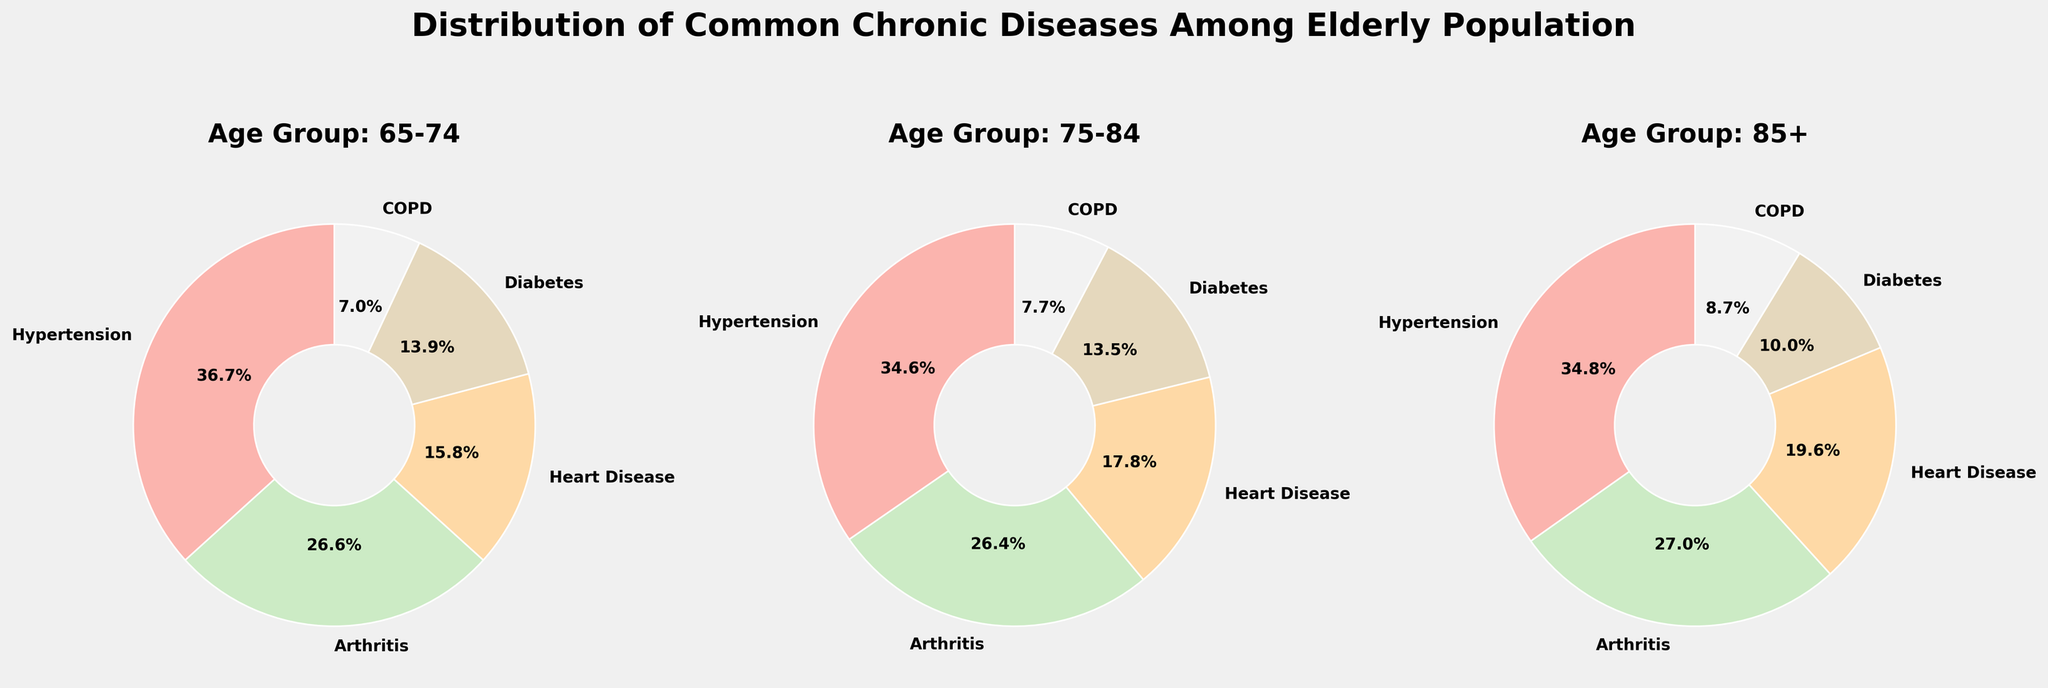what is the title of the figure? The title is typically displayed at the top of the plot to give viewers an idea of what the figure is about. The title is "Distribution of Common Chronic Diseases Among Elderly Population".
Answer: Distribution of Common Chronic Diseases Among Elderly Population Which age group has the highest percentage of people with Hypertension? Look at each subplot for the age groups 65-74, 75-84, and 85+. Compare the percentages of Hypertension in each pie chart. The highest percentage is seen in the 85+ age group.
Answer: 85+ Which disease has the smallest percentage in the age group 65-74? Look at the pie chart for the 65-74 age group and identify the slice with the smallest percentage. The smallest percentage slice is for COPD.
Answer: COPD What is the combined percentage of Hypertension and Arthritis in the 75-84 age group? To find this, add the percentage of Hypertension (72%) and Arthritis (55%) in the 75-84 age group. 72 + 55 = 127.
Answer: 127% Which two diseases have nearly equal percentages in the 85+ age group? Look at the pie chart for the 85+ age group and compare the slices. Diabetes and COPD have nearly equal percentages (23% and 20%).
Answer: Diabetes and COPD What is the total percentage accounted for by Heart Disease in all age groups combined? Sum the percentages for Heart Disease in each age group: 25% (65-74) + 37% (75-84) + 45% (85+). 25 + 37 + 45 = 107.
Answer: 107% How does the percentage of people with COPD change across age groups? Compare the percentage slices for COPD in each age group: 11% (65-74), 16% (75-84), 20% (85+). The percentage increases with each older age group.
Answer: Increases Which age group has the smallest percentage of Diabetes, and what is that percentage? Compare the percentage slices for Diabetes in each age group: 22% (65-74), 28% (75-84), 23% (85+). The smallest percentage is 22% in the 65-74 age group.
Answer: 65-74, 22% Between the 75-84 and 85+ age groups, which has a larger difference in percentages between Heart Disease and Diabetes? Calculate the difference for each age group: 75-84: 37% (Heart Disease) - 28% (Diabetes) = 9. 85+: 45% (Heart Disease) - 23% (Diabetes) = 22. The 85+ age group has a larger difference of 22.
Answer: 85+ 